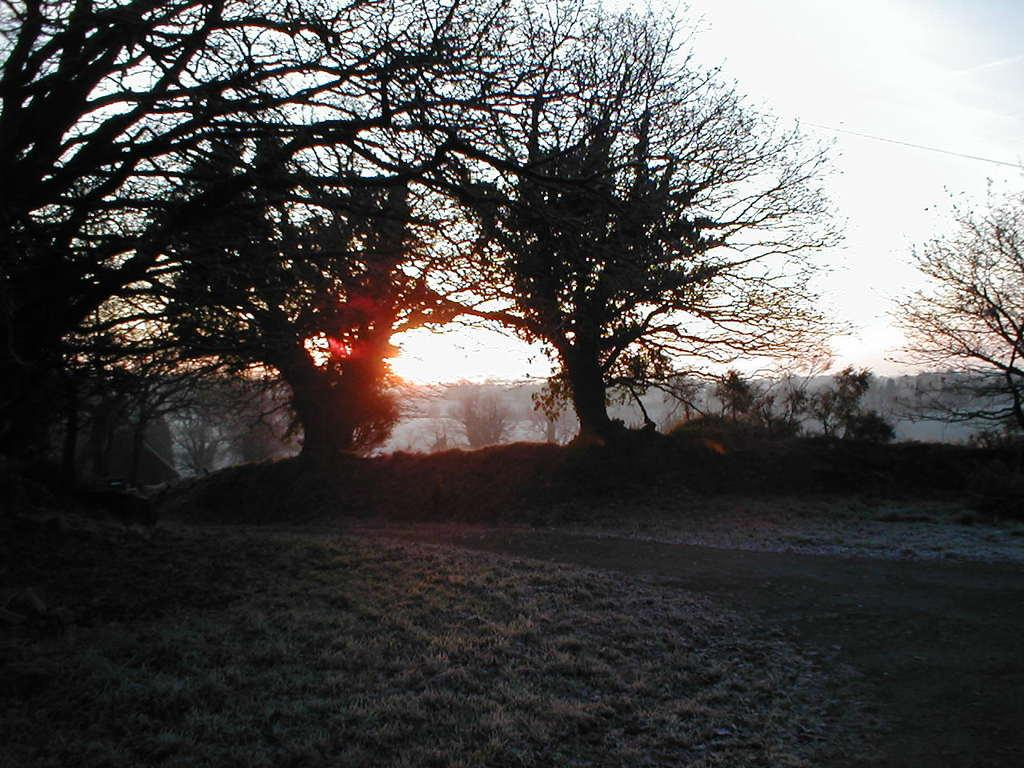What type of vegetation can be seen in the image? There are trees in the image. What time of day is depicted in the image? There is a sunrise in the image, indicating that it is early morning. What type of terrain is on the left side of the image? There is a grassland on the left side of the image. What channel is the knee watching in the image? There is no mention of a knee or a channel in the image, as it features trees and a sunrise over a grassland. 